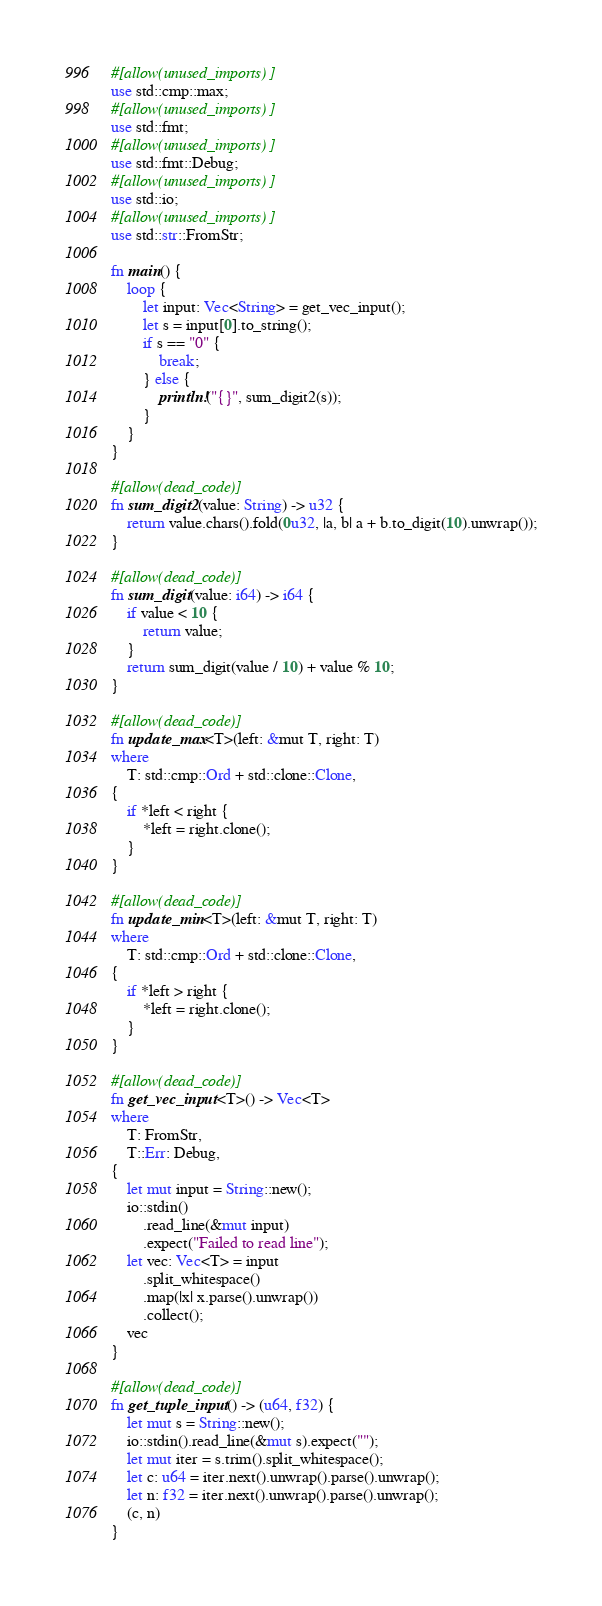<code> <loc_0><loc_0><loc_500><loc_500><_Rust_>#[allow(unused_imports)]
use std::cmp::max;
#[allow(unused_imports)]
use std::fmt;
#[allow(unused_imports)]
use std::fmt::Debug;
#[allow(unused_imports)]
use std::io;
#[allow(unused_imports)]
use std::str::FromStr;

fn main() {
    loop {
        let input: Vec<String> = get_vec_input();
        let s = input[0].to_string();
        if s == "0" {
            break;
        } else {
            println!("{}", sum_digit2(s));
        }
    }
}

#[allow(dead_code)]
fn sum_digit2(value: String) -> u32 {
    return value.chars().fold(0u32, |a, b| a + b.to_digit(10).unwrap());
}

#[allow(dead_code)]
fn sum_digit(value: i64) -> i64 {
    if value < 10 {
        return value;
    }
    return sum_digit(value / 10) + value % 10;
}

#[allow(dead_code)]
fn update_max<T>(left: &mut T, right: T)
where
    T: std::cmp::Ord + std::clone::Clone,
{
    if *left < right {
        *left = right.clone();
    }
}

#[allow(dead_code)]
fn update_min<T>(left: &mut T, right: T)
where
    T: std::cmp::Ord + std::clone::Clone,
{
    if *left > right {
        *left = right.clone();
    }
}

#[allow(dead_code)]
fn get_vec_input<T>() -> Vec<T>
where
    T: FromStr,
    T::Err: Debug,
{
    let mut input = String::new();
    io::stdin()
        .read_line(&mut input)
        .expect("Failed to read line");
    let vec: Vec<T> = input
        .split_whitespace()
        .map(|x| x.parse().unwrap())
        .collect();
    vec
}

#[allow(dead_code)]
fn get_tuple_input() -> (u64, f32) {
    let mut s = String::new();
    io::stdin().read_line(&mut s).expect("");
    let mut iter = s.trim().split_whitespace();
    let c: u64 = iter.next().unwrap().parse().unwrap();
    let n: f32 = iter.next().unwrap().parse().unwrap();
    (c, n)
}

</code> 